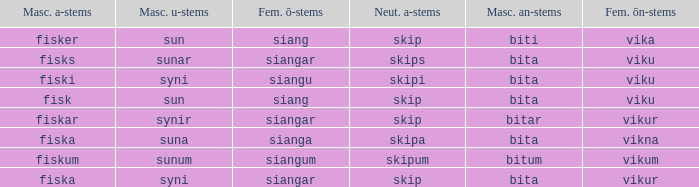What is the an-stem for the word which has an ö-stems of siangar and an u-stem ending of syni? Bita. Can you parse all the data within this table? {'header': ['Masc. a-stems', 'Masc. u-stems', 'Fem. ō-stems', 'Neut. a-stems', 'Masc. an-stems', 'Fem. ōn-stems'], 'rows': [['fisker', 'sun', 'siang', 'skip', 'biti', 'vika'], ['fisks', 'sunar', 'siangar', 'skips', 'bita', 'viku'], ['fiski', 'syni', 'siangu', 'skipi', 'bita', 'viku'], ['fisk', 'sun', 'siang', 'skip', 'bita', 'viku'], ['fiskar', 'synir', 'siangar', 'skip', 'bitar', 'vikur'], ['fiska', 'suna', 'sianga', 'skipa', 'bita', 'vikna'], ['fiskum', 'sunum', 'siangum', 'skipum', 'bitum', 'vikum'], ['fiska', 'syni', 'siangar', 'skip', 'bita', 'vikur']]} 